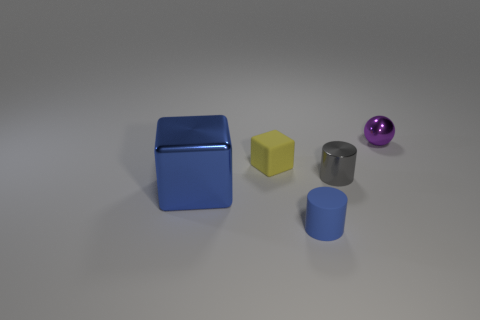Add 2 balls. How many objects exist? 7 Subtract 1 balls. How many balls are left? 0 Subtract all gray cylinders. How many cylinders are left? 1 Subtract all cubes. How many objects are left? 3 Subtract all yellow balls. Subtract all red blocks. How many balls are left? 1 Subtract all tiny yellow metal blocks. Subtract all blue matte things. How many objects are left? 4 Add 4 blue metal cubes. How many blue metal cubes are left? 5 Add 4 tiny purple rubber things. How many tiny purple rubber things exist? 4 Subtract 0 green cylinders. How many objects are left? 5 